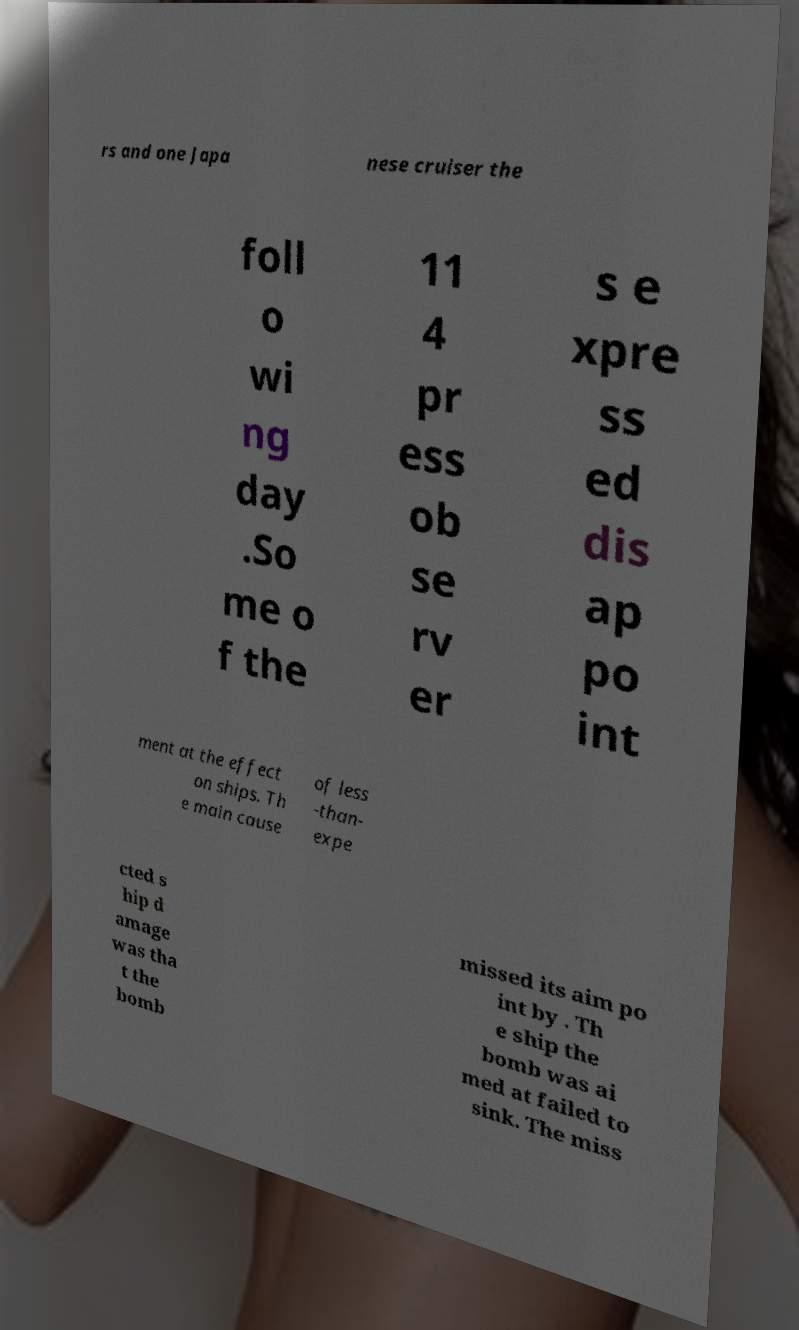Please read and relay the text visible in this image. What does it say? rs and one Japa nese cruiser the foll o wi ng day .So me o f the 11 4 pr ess ob se rv er s e xpre ss ed dis ap po int ment at the effect on ships. Th e main cause of less -than- expe cted s hip d amage was tha t the bomb missed its aim po int by . Th e ship the bomb was ai med at failed to sink. The miss 